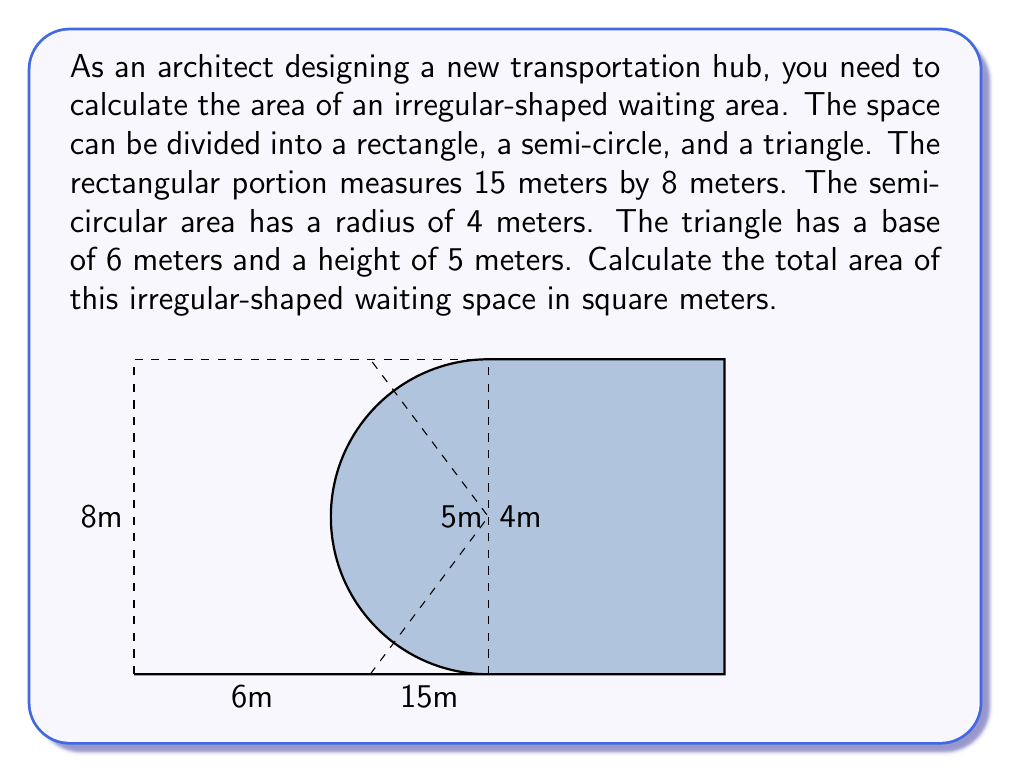Teach me how to tackle this problem. To solve this problem, we need to calculate the areas of each component and then sum them up:

1. Area of the rectangle:
   $A_r = l \times w = 15 \text{ m} \times 8 \text{ m} = 120 \text{ m}^2$

2. Area of the semi-circle:
   $A_s = \frac{1}{2} \times \pi r^2 = \frac{1}{2} \times \pi \times (4 \text{ m})^2 = 8\pi \text{ m}^2$

3. Area of the triangle:
   $A_t = \frac{1}{2} \times b \times h = \frac{1}{2} \times 6 \text{ m} \times 5 \text{ m} = 15 \text{ m}^2$

Now, we need to subtract the areas of the semi-circle and triangle from the rectangle:

Total Area = $A_r - A_s - A_t$

$$\begin{align*}
\text{Total Area} &= 120 \text{ m}^2 - 8\pi \text{ m}^2 - 15 \text{ m}^2 \\
&= 105 - 8\pi \text{ m}^2 \\
&\approx 79.86 \text{ m}^2
\end{align*}$$
Answer: The total area of the irregular-shaped waiting space is $105 - 8\pi \text{ m}^2$, or approximately 79.86 m². 